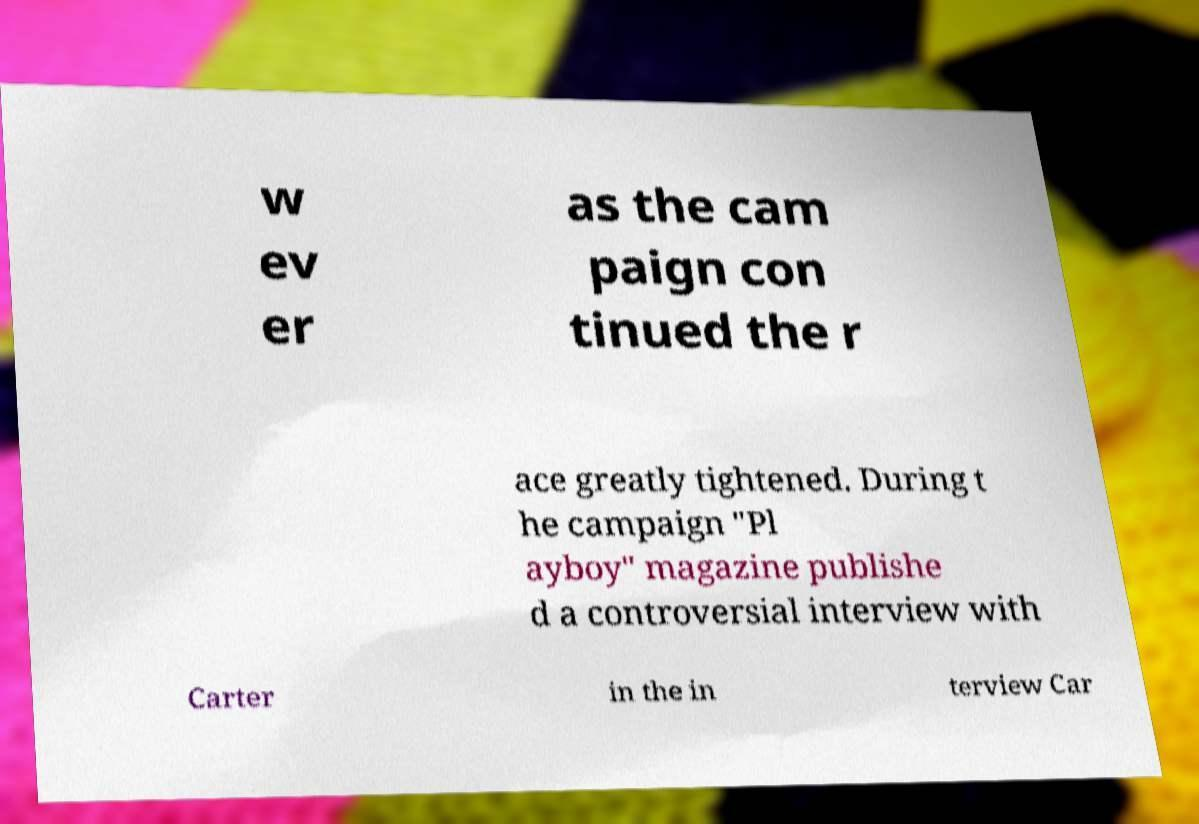What messages or text are displayed in this image? I need them in a readable, typed format. w ev er as the cam paign con tinued the r ace greatly tightened. During t he campaign "Pl ayboy" magazine publishe d a controversial interview with Carter in the in terview Car 